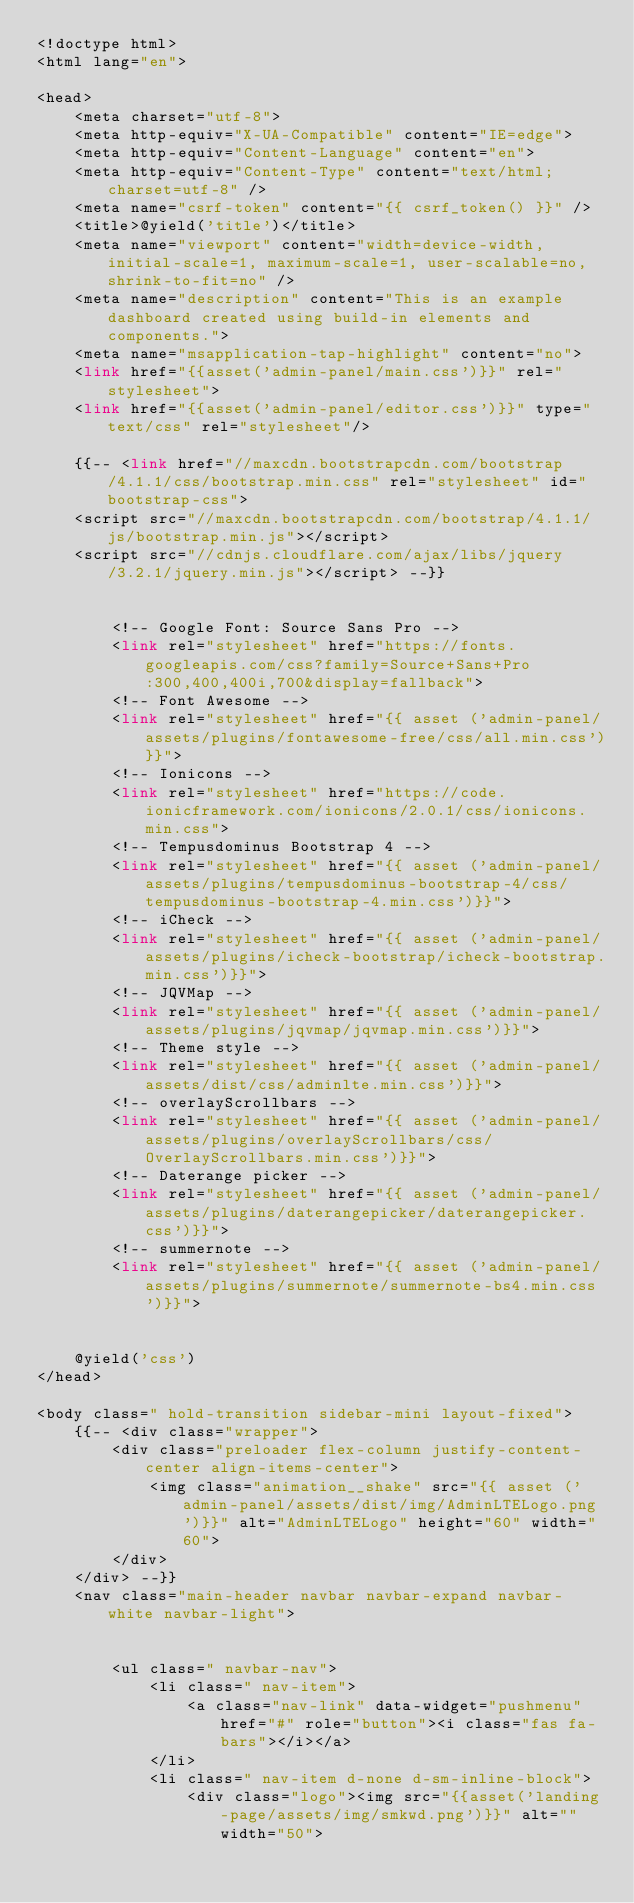Convert code to text. <code><loc_0><loc_0><loc_500><loc_500><_PHP_><!doctype html>
<html lang="en">

<head>
    <meta charset="utf-8">
    <meta http-equiv="X-UA-Compatible" content="IE=edge">
    <meta http-equiv="Content-Language" content="en">
    <meta http-equiv="Content-Type" content="text/html; charset=utf-8" />
    <meta name="csrf-token" content="{{ csrf_token() }}" />
    <title>@yield('title')</title>
    <meta name="viewport" content="width=device-width, initial-scale=1, maximum-scale=1, user-scalable=no, shrink-to-fit=no" />
    <meta name="description" content="This is an example dashboard created using build-in elements and components.">
    <meta name="msapplication-tap-highlight" content="no">
    <link href="{{asset('admin-panel/main.css')}}" rel="stylesheet">
    <link href="{{asset('admin-panel/editor.css')}}" type="text/css" rel="stylesheet"/>
    
	{{-- <link href="//maxcdn.bootstrapcdn.com/bootstrap/4.1.1/css/bootstrap.min.css" rel="stylesheet" id="bootstrap-css">
	<script src="//maxcdn.bootstrapcdn.com/bootstrap/4.1.1/js/bootstrap.min.js"></script>
	<script src="//cdnjs.cloudflare.com/ajax/libs/jquery/3.2.1/jquery.min.js"></script> --}}


        <!-- Google Font: Source Sans Pro -->
        <link rel="stylesheet" href="https://fonts.googleapis.com/css?family=Source+Sans+Pro:300,400,400i,700&display=fallback">
        <!-- Font Awesome -->
        <link rel="stylesheet" href="{{ asset ('admin-panel/assets/plugins/fontawesome-free/css/all.min.css')}}">
        <!-- Ionicons -->
        <link rel="stylesheet" href="https://code.ionicframework.com/ionicons/2.0.1/css/ionicons.min.css">
        <!-- Tempusdominus Bootstrap 4 -->
        <link rel="stylesheet" href="{{ asset ('admin-panel/assets/plugins/tempusdominus-bootstrap-4/css/tempusdominus-bootstrap-4.min.css')}}">
        <!-- iCheck -->
        <link rel="stylesheet" href="{{ asset ('admin-panel/assets/plugins/icheck-bootstrap/icheck-bootstrap.min.css')}}">
        <!-- JQVMap -->
        <link rel="stylesheet" href="{{ asset ('admin-panel/assets/plugins/jqvmap/jqvmap.min.css')}}">
        <!-- Theme style -->
        <link rel="stylesheet" href="{{ asset ('admin-panel/assets/dist/css/adminlte.min.css')}}">
        <!-- overlayScrollbars -->
        <link rel="stylesheet" href="{{ asset ('admin-panel/assets/plugins/overlayScrollbars/css/OverlayScrollbars.min.css')}}">
        <!-- Daterange picker -->
        <link rel="stylesheet" href="{{ asset ('admin-panel/assets/plugins/daterangepicker/daterangepicker.css')}}">
        <!-- summernote -->
        <link rel="stylesheet" href="{{ asset ('admin-panel/assets/plugins/summernote/summernote-bs4.min.css')}}">


    @yield('css')
</head>

<body class=" hold-transition sidebar-mini layout-fixed">
    {{-- <div class="wrapper">
        <div class="preloader flex-column justify-content-center align-items-center">
            <img class="animation__shake" src="{{ asset ('admin-panel/assets/dist/img/AdminLTELogo.png')}}" alt="AdminLTELogo" height="60" width="60">
        </div>
    </div> --}}
    <nav class="main-header navbar navbar-expand navbar-white navbar-light">


        <ul class=" navbar-nav">
            <li class=" nav-item">
                <a class="nav-link" data-widget="pushmenu" href="#" role="button"><i class="fas fa-bars"></i></a>
            </li>
            <li class=" nav-item d-none d-sm-inline-block">
                <div class="logo"><img src="{{asset('landing-page/assets/img/smkwd.png')}}" alt="" width="50"></code> 